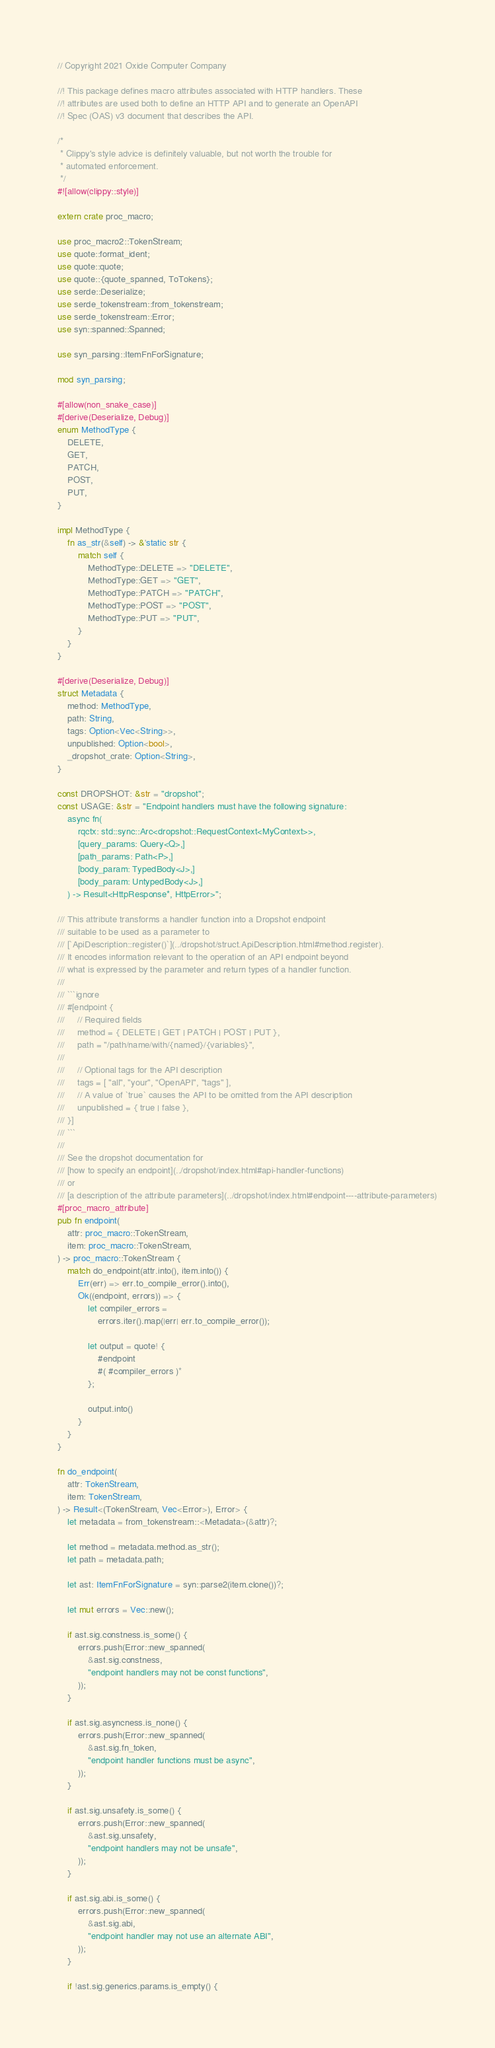Convert code to text. <code><loc_0><loc_0><loc_500><loc_500><_Rust_>// Copyright 2021 Oxide Computer Company

//! This package defines macro attributes associated with HTTP handlers. These
//! attributes are used both to define an HTTP API and to generate an OpenAPI
//! Spec (OAS) v3 document that describes the API.

/*
 * Clippy's style advice is definitely valuable, but not worth the trouble for
 * automated enforcement.
 */
#![allow(clippy::style)]

extern crate proc_macro;

use proc_macro2::TokenStream;
use quote::format_ident;
use quote::quote;
use quote::{quote_spanned, ToTokens};
use serde::Deserialize;
use serde_tokenstream::from_tokenstream;
use serde_tokenstream::Error;
use syn::spanned::Spanned;

use syn_parsing::ItemFnForSignature;

mod syn_parsing;

#[allow(non_snake_case)]
#[derive(Deserialize, Debug)]
enum MethodType {
    DELETE,
    GET,
    PATCH,
    POST,
    PUT,
}

impl MethodType {
    fn as_str(&self) -> &'static str {
        match self {
            MethodType::DELETE => "DELETE",
            MethodType::GET => "GET",
            MethodType::PATCH => "PATCH",
            MethodType::POST => "POST",
            MethodType::PUT => "PUT",
        }
    }
}

#[derive(Deserialize, Debug)]
struct Metadata {
    method: MethodType,
    path: String,
    tags: Option<Vec<String>>,
    unpublished: Option<bool>,
    _dropshot_crate: Option<String>,
}

const DROPSHOT: &str = "dropshot";
const USAGE: &str = "Endpoint handlers must have the following signature:
    async fn(
        rqctx: std::sync::Arc<dropshot::RequestContext<MyContext>>,
        [query_params: Query<Q>,]
        [path_params: Path<P>,]
        [body_param: TypedBody<J>,]
        [body_param: UntypedBody<J>,]
    ) -> Result<HttpResponse*, HttpError>";

/// This attribute transforms a handler function into a Dropshot endpoint
/// suitable to be used as a parameter to
/// [`ApiDescription::register()`](../dropshot/struct.ApiDescription.html#method.register).
/// It encodes information relevant to the operation of an API endpoint beyond
/// what is expressed by the parameter and return types of a handler function.
///
/// ```ignore
/// #[endpoint {
///     // Required fields
///     method = { DELETE | GET | PATCH | POST | PUT },
///     path = "/path/name/with/{named}/{variables}",
///
///     // Optional tags for the API description
///     tags = [ "all", "your", "OpenAPI", "tags" ],
///     // A value of `true` causes the API to be omitted from the API description
///     unpublished = { true | false },
/// }]
/// ```
///
/// See the dropshot documentation for
/// [how to specify an endpoint](../dropshot/index.html#api-handler-functions)
/// or
/// [a description of the attribute parameters](../dropshot/index.html#endpoint----attribute-parameters)
#[proc_macro_attribute]
pub fn endpoint(
    attr: proc_macro::TokenStream,
    item: proc_macro::TokenStream,
) -> proc_macro::TokenStream {
    match do_endpoint(attr.into(), item.into()) {
        Err(err) => err.to_compile_error().into(),
        Ok((endpoint, errors)) => {
            let compiler_errors =
                errors.iter().map(|err| err.to_compile_error());

            let output = quote! {
                #endpoint
                #( #compiler_errors )*
            };

            output.into()
        }
    }
}

fn do_endpoint(
    attr: TokenStream,
    item: TokenStream,
) -> Result<(TokenStream, Vec<Error>), Error> {
    let metadata = from_tokenstream::<Metadata>(&attr)?;

    let method = metadata.method.as_str();
    let path = metadata.path;

    let ast: ItemFnForSignature = syn::parse2(item.clone())?;

    let mut errors = Vec::new();

    if ast.sig.constness.is_some() {
        errors.push(Error::new_spanned(
            &ast.sig.constness,
            "endpoint handlers may not be const functions",
        ));
    }

    if ast.sig.asyncness.is_none() {
        errors.push(Error::new_spanned(
            &ast.sig.fn_token,
            "endpoint handler functions must be async",
        ));
    }

    if ast.sig.unsafety.is_some() {
        errors.push(Error::new_spanned(
            &ast.sig.unsafety,
            "endpoint handlers may not be unsafe",
        ));
    }

    if ast.sig.abi.is_some() {
        errors.push(Error::new_spanned(
            &ast.sig.abi,
            "endpoint handler may not use an alternate ABI",
        ));
    }

    if !ast.sig.generics.params.is_empty() {</code> 